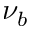Convert formula to latex. <formula><loc_0><loc_0><loc_500><loc_500>\nu _ { b }</formula> 